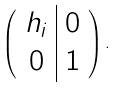Convert formula to latex. <formula><loc_0><loc_0><loc_500><loc_500>\left ( \begin{array} { c | c } h _ { i } & 0 \\ 0 & 1 \end{array} \right ) .</formula> 